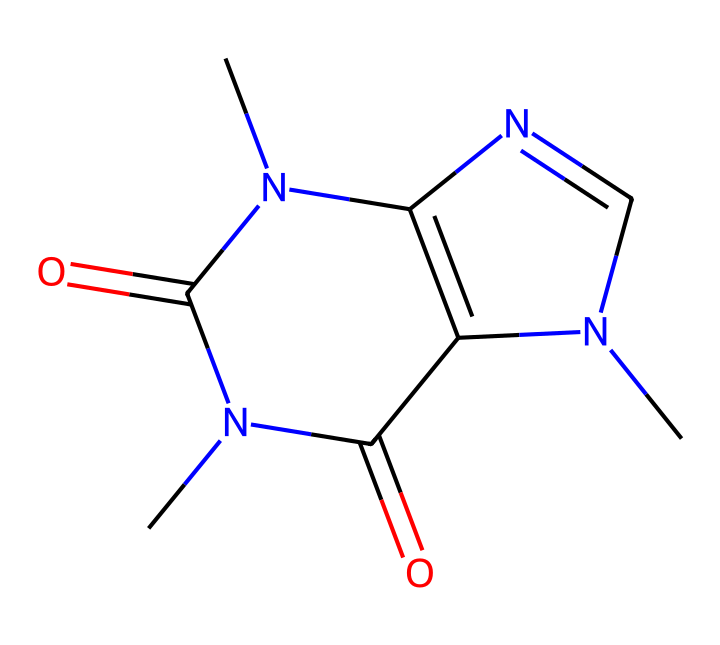What is the molecular formula for caffeine? To determine the molecular formula from the SMILES representation, we identify the types and counts of atoms present in the structure. The SMILES indicates elements: C (carbon), N (nitrogen), and O (oxygen). By analyzing the structure, we find there are 8 carbons, 10 hydrogens, 4 nitrogens, and 2 oxygens, leading to the molecular formula C8H10N4O2.
Answer: C8H10N4O2 How many chiral centers does caffeine have? To find the number of chiral centers in caffeine, we look at the stereocenters in the structure. A chiral center is typically a carbon atom bonded to four different groups. In caffeine's structure, there is only one carbon atom, in the central ring, that fits this definition. Thus, caffeine has one chiral center.
Answer: 1 What type of compound is caffeine classified as? Caffeine is an alkaloid, a type of nitrogen-containing compound that generally has a physiological effect on humans and animals. Its structure showcases multiple nitrogen atoms, confirming its classification as an alkaloid.
Answer: alkaloid What is the total number of atoms present in caffeine? To find the total number of atoms in caffeine, we sum the counts of each type of atom based on the molecular formula derived earlier. Caffeine has 8 carbons, 10 hydrogens, 4 nitrogens, and 2 oxygens, leading to a total of 24 atoms when summed.
Answer: 24 How many rings are in the structure of caffeine? By examining the SMILES representation and analyzing the structure, we can see that caffeine consists of two interconnected ring structures. The information depicts its bicyclic structure.
Answer: 2 Is caffeine optically active? Since caffeine has a chiral center, it can exhibit optical activity. This means that it can rotate plane-polarized light due to the presence of its asymmetric carbon atom. Hence, caffeine is considered optically active.
Answer: yes 